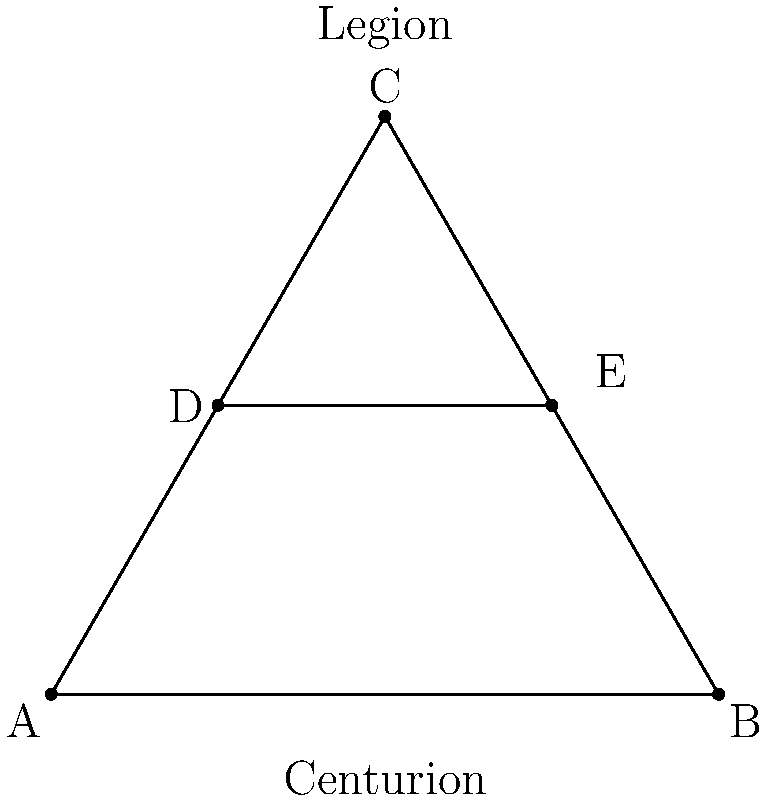In the Roman military formation shown above, which represents a typical manipular legion arrangement, what is the ratio of the length of line DE to the base of the triangle ABC? To solve this problem, we need to follow these steps:

1. Recognize that the triangle ABC is an equilateral triangle, as it represents a standard Roman formation.

2. In an equilateral triangle, the height (h) is related to the side length (s) by the formula:
   $$h = \frac{\sqrt{3}}{2} s$$

3. The base of the triangle (AB) is 4 units long, so the height (AC) is:
   $$h = \frac{\sqrt{3}}{2} \cdot 4 = 2\sqrt{3}$$

4. Line DE is parallel to AB and is positioned at half the height of the triangle. Its length can be calculated using the property of similar triangles:
   $$\frac{DE}{AB} = \frac{1/2 \cdot AC}{AC} = \frac{1}{2}$$

5. Therefore, the length of DE is half the length of AB:
   $$DE = \frac{1}{2} \cdot 4 = 2$$

6. The ratio of DE to AB is thus:
   $$\frac{DE}{AB} = \frac{2}{4} = \frac{1}{2}$$

This ratio of 1:2 represents the typical proportion in Roman manipular legion formations, where the second line (represented by DE) was often half the width of the front line (represented by AB).
Answer: 1:2 